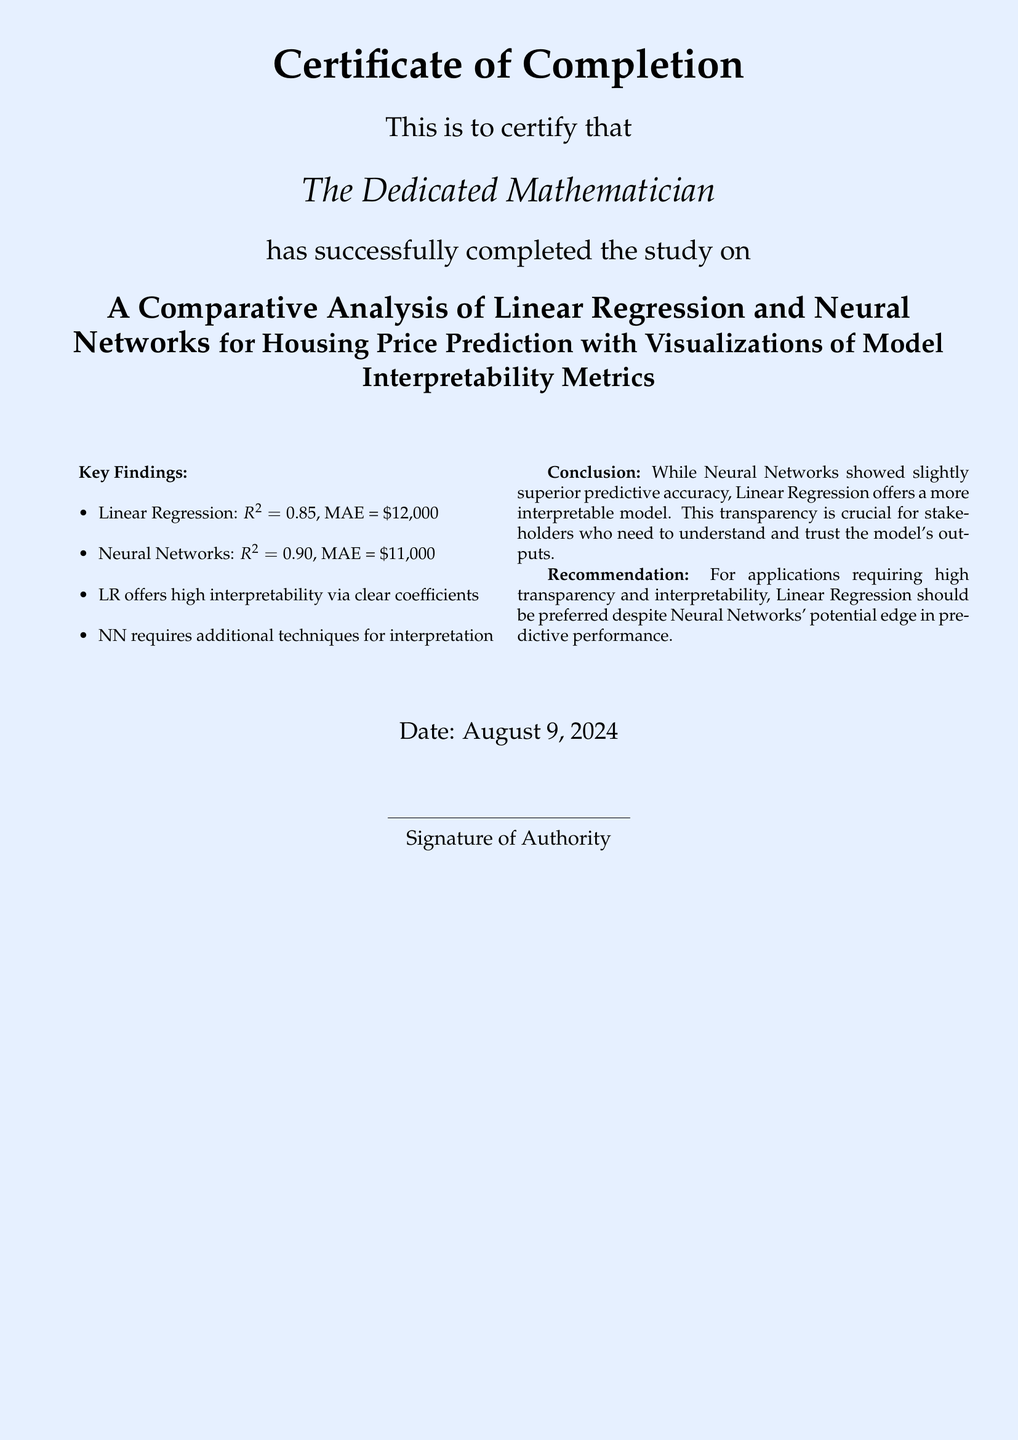What is the title of the study? The title of the study is explicitly presented in a bold format within the document.
Answer: A Comparative Analysis of Linear Regression and Neural Networks for Housing Price Prediction with Visualizations of Model Interpretability Metrics What is the MAE for Linear Regression? The MAE for Linear Regression is stated in the key findings section of the document.
Answer: $12,000 What is the R-squared value for Neural Networks? The R-squared value for Neural Networks is provided in the list of key findings.
Answer: 0.90 What is the key advantage of Linear Regression mentioned? The document highlights a specific trait of Linear Regression in the key findings section.
Answer: High interpretability via clear coefficients What is the main recommendation given in the document? The recommendation outlines the preferred model based on transparency and interpretability.
Answer: Linear Regression should be preferred On what date was the document completed? The date is provided at the bottom of the document, indicating when the study was finalized.
Answer: Today's date What is the conclusion regarding the transparency of the models? The conclusion section summarizes the findings about the models' transparency.
Answer: Transparency is crucial for stakeholders What is the MAE for Neural Networks? The MAE for Neural Networks is listed among the key findings of the document.
Answer: $11,000 Who completed the study? The name attributed to the completion of the study is specified at the top of the document.
Answer: The Dedicated Mathematician 